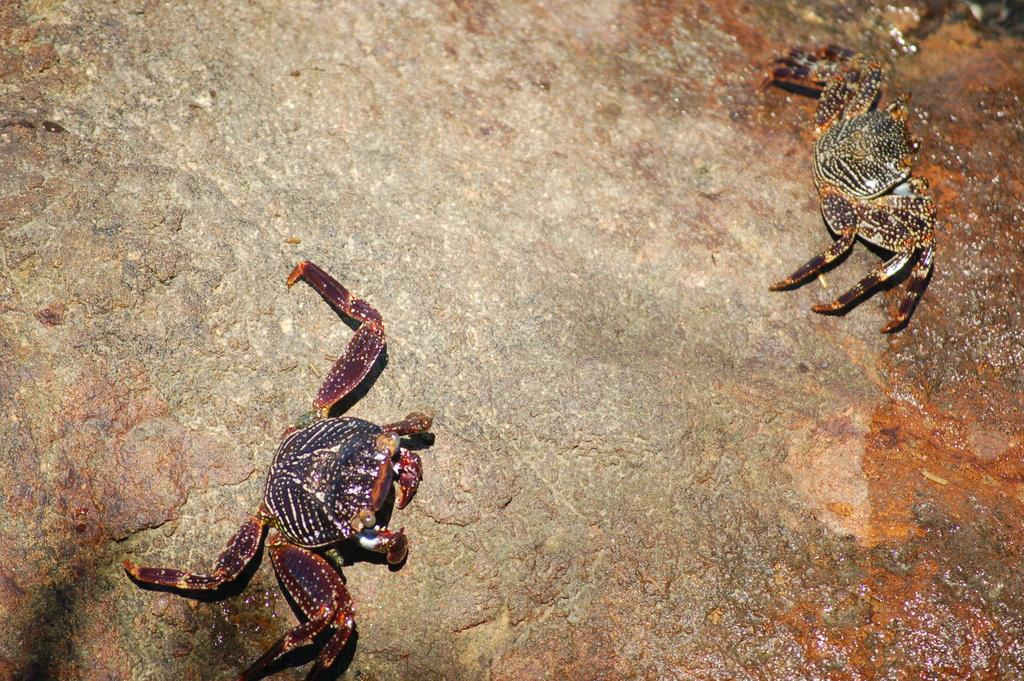What type of animals are on the ground in the image? There are crabs on the ground in the image. How many goats can be seen climbing the wall in the image? There are no goats or walls present in the image; it features crabs on the ground. 